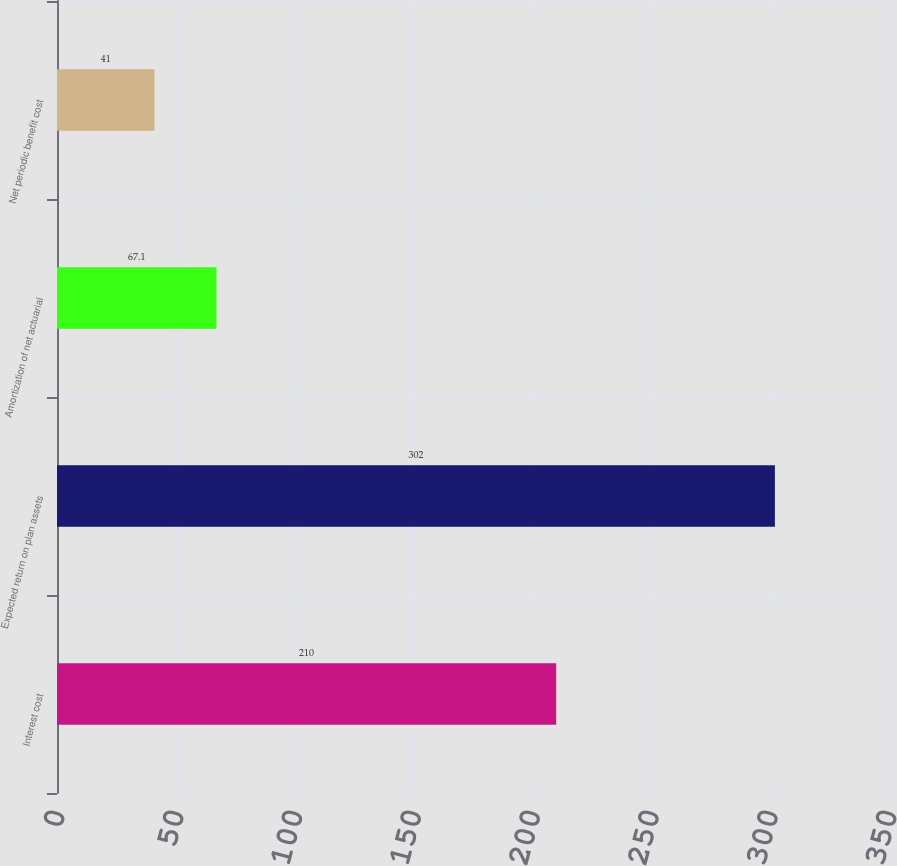Convert chart to OTSL. <chart><loc_0><loc_0><loc_500><loc_500><bar_chart><fcel>Interest cost<fcel>Expected return on plan assets<fcel>Amortization of net actuarial<fcel>Net periodic benefit cost<nl><fcel>210<fcel>302<fcel>67.1<fcel>41<nl></chart> 